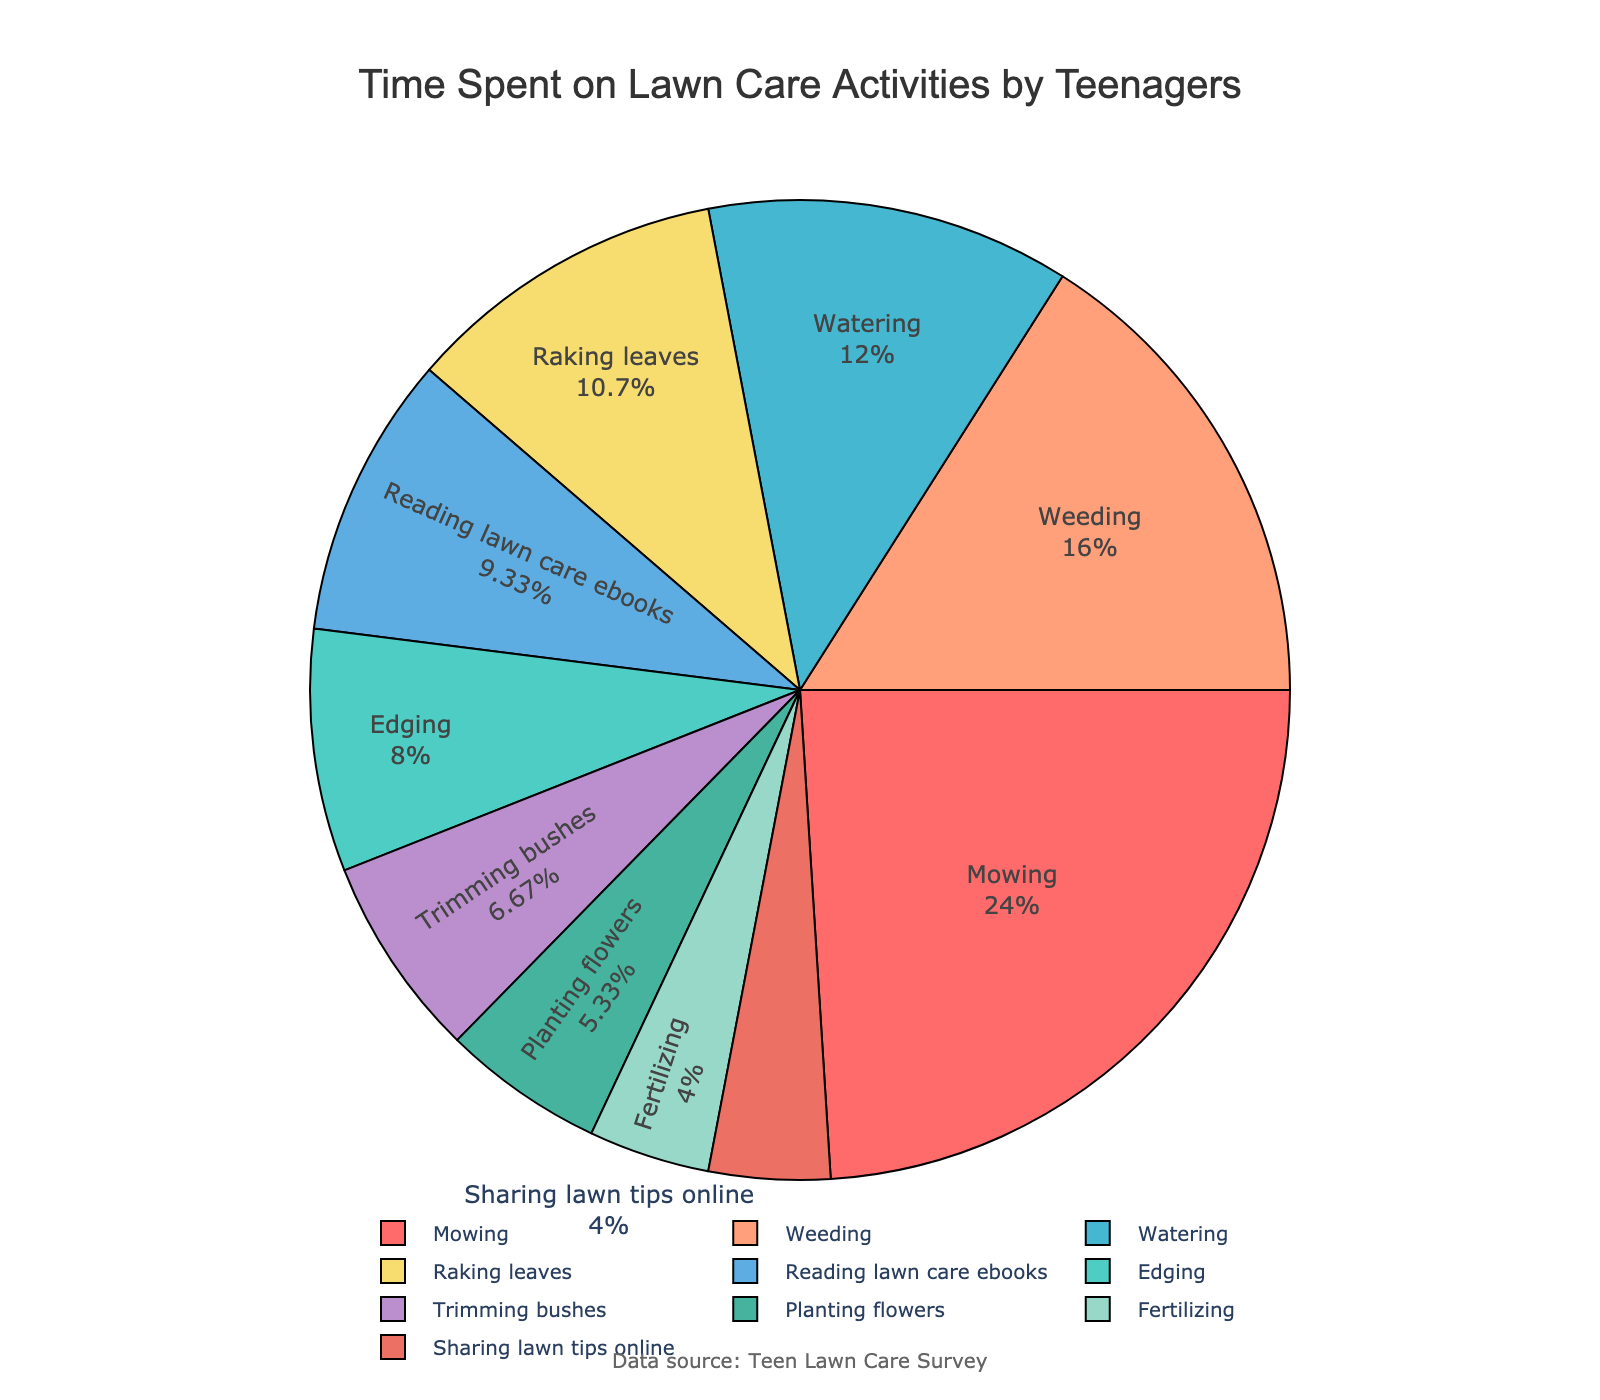Which activity takes up the most time? Mowing occupies the largest percentage in the pie chart.
Answer: Mowing Which two activities together take up the same amount of time as weeding? Reading lawn care ebooks and raking leaves together account for (35 + 40) = 75 minutes, which is slightly more than weeding's 60 minutes. However, edging (30) and watering (45) sum to 75, slightly more than weeding.
Answer: Reading lawn care ebooks and raking leaves What percentage of time is spent on watering compared to mowing? Mowing takes 90 minutes, watering takes 45 minutes. 45/90 = 0.5, so watering is 50% of the time spent on mowing.
Answer: 50% Compare the time spent on weeding and raking leaves. Which one is greater and by how much? Weeding takes 60 minutes, and raking leaves takes 40 minutes. 60 - 40 = 20 minutes more for weeding.
Answer: Weeding by 20 minutes What percentage of time is spent on reading lawn care ebooks? The pie chart shows that reading lawn care ebooks takes up a specific percentage of the total activities.
Answer: 10.6% Which activities together amount to exactly half of the total time spent? Mowing (90), edging (30), and watering (45) sum to 165 minutes, exactly half of the total 330 minutes.
Answer: Mowing, edging, and watering Of the following, which is performed least often: fertilizing, trimming bushes, or planting flowers? The pie chart shows that fertilizing is the activity with the smallest section.
Answer: Fertilizing What is the combined percentage of the two smallest activities? Fertilizing (15) and sharing lawn tips online (15) combine for 30 minutes. 30/330 * 100% = 9.1%.
Answer: 9.1% Which activities require more time: planting flowers and trimming bushes, or reading lawn care ebooks and sharing lawn tips online? Planting flowers (20) and trimming bushes (25) total 45 minutes, whereas reading lawn care ebooks (35) and sharing lawn tips online (15) total 50 minutes. Therefore, reading lawn care ebooks and sharing lawn tips online require more time.
Answer: Reading lawn care ebooks and sharing lawn tips online How does the time spent on edging compare to the time spent on trimming bushes? Edging takes 30 minutes, and trimming bushes takes 25 minutes. Edging takes 5 minutes more than trimming bushes.
Answer: Edging by 5 minutes 